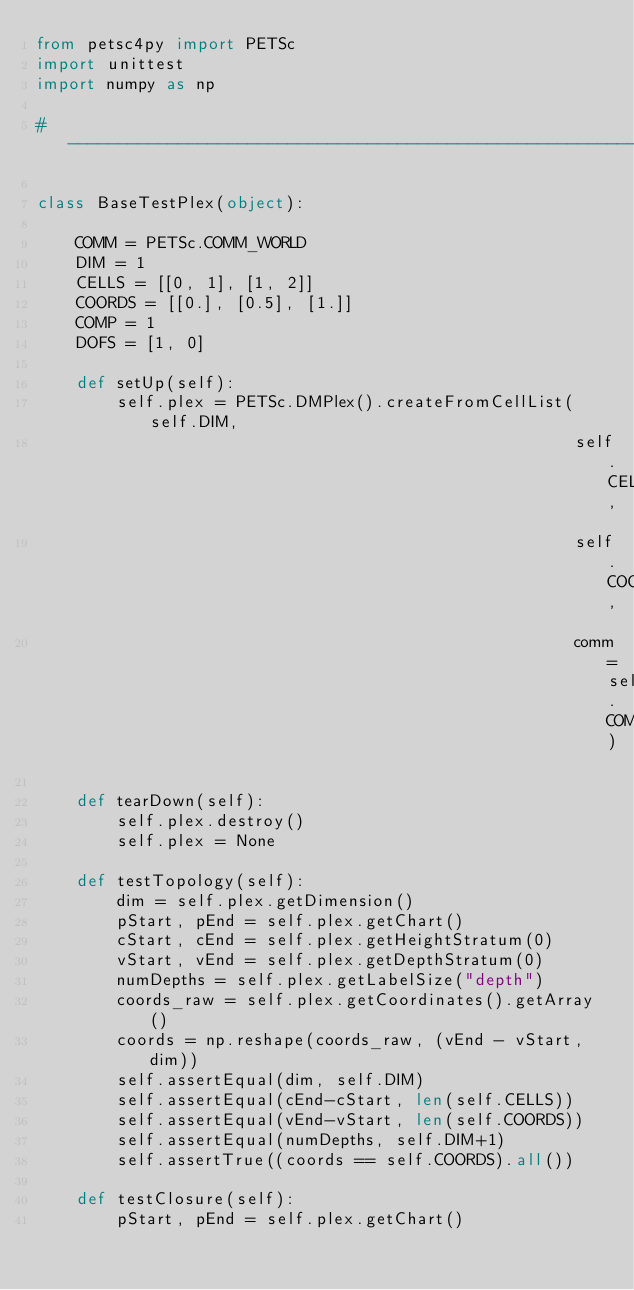Convert code to text. <code><loc_0><loc_0><loc_500><loc_500><_Python_>from petsc4py import PETSc
import unittest
import numpy as np

# --------------------------------------------------------------------

class BaseTestPlex(object):

    COMM = PETSc.COMM_WORLD
    DIM = 1
    CELLS = [[0, 1], [1, 2]]
    COORDS = [[0.], [0.5], [1.]]
    COMP = 1
    DOFS = [1, 0]

    def setUp(self):
        self.plex = PETSc.DMPlex().createFromCellList(self.DIM,
                                                      self.CELLS,
                                                      self.COORDS,
                                                      comm=self.COMM)

    def tearDown(self):
        self.plex.destroy()
        self.plex = None

    def testTopology(self):
        dim = self.plex.getDimension()
        pStart, pEnd = self.plex.getChart()
        cStart, cEnd = self.plex.getHeightStratum(0)
        vStart, vEnd = self.plex.getDepthStratum(0)
        numDepths = self.plex.getLabelSize("depth")
        coords_raw = self.plex.getCoordinates().getArray()
        coords = np.reshape(coords_raw, (vEnd - vStart, dim))
        self.assertEqual(dim, self.DIM)
        self.assertEqual(cEnd-cStart, len(self.CELLS))
        self.assertEqual(vEnd-vStart, len(self.COORDS))
        self.assertEqual(numDepths, self.DIM+1)
        self.assertTrue((coords == self.COORDS).all())

    def testClosure(self):
        pStart, pEnd = self.plex.getChart()</code> 